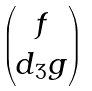<formula> <loc_0><loc_0><loc_500><loc_500>\begin{pmatrix} f \\ d _ { 3 } g \end{pmatrix}</formula> 